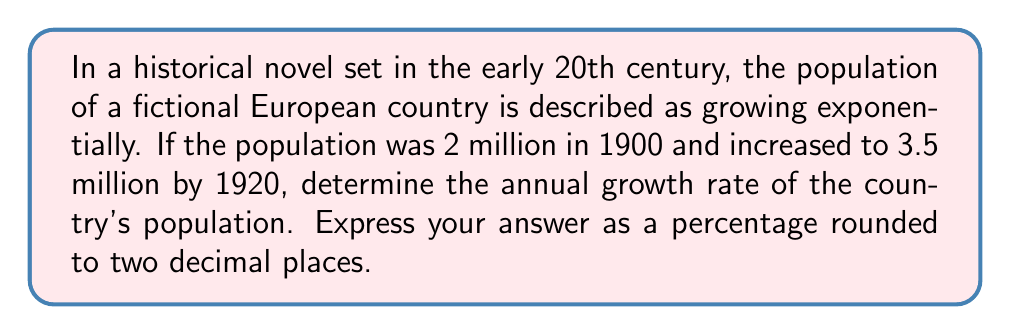Could you help me with this problem? Let's approach this step-by-step using the exponential growth formula:

1) The exponential growth formula is:
   $A = P(1 + r)^t$
   Where:
   $A$ is the final amount
   $P$ is the initial amount
   $r$ is the growth rate (in decimal form)
   $t$ is the time period

2) We know:
   $P = 2$ million (initial population in 1900)
   $A = 3.5$ million (final population in 1920)
   $t = 20$ years

3) Let's substitute these values into the formula:
   $3.5 = 2(1 + r)^{20}$

4) Divide both sides by 2:
   $1.75 = (1 + r)^{20}$

5) Take the 20th root of both sides:
   $\sqrt[20]{1.75} = 1 + r$

6) Subtract 1 from both sides:
   $\sqrt[20]{1.75} - 1 = r$

7) Calculate:
   $r = 1.0282... - 1 = 0.0282...$

8) Convert to a percentage by multiplying by 100:
   $0.0282... * 100 = 2.82...\%$

9) Rounding to two decimal places:
   $2.82\%$
Answer: 2.82% 